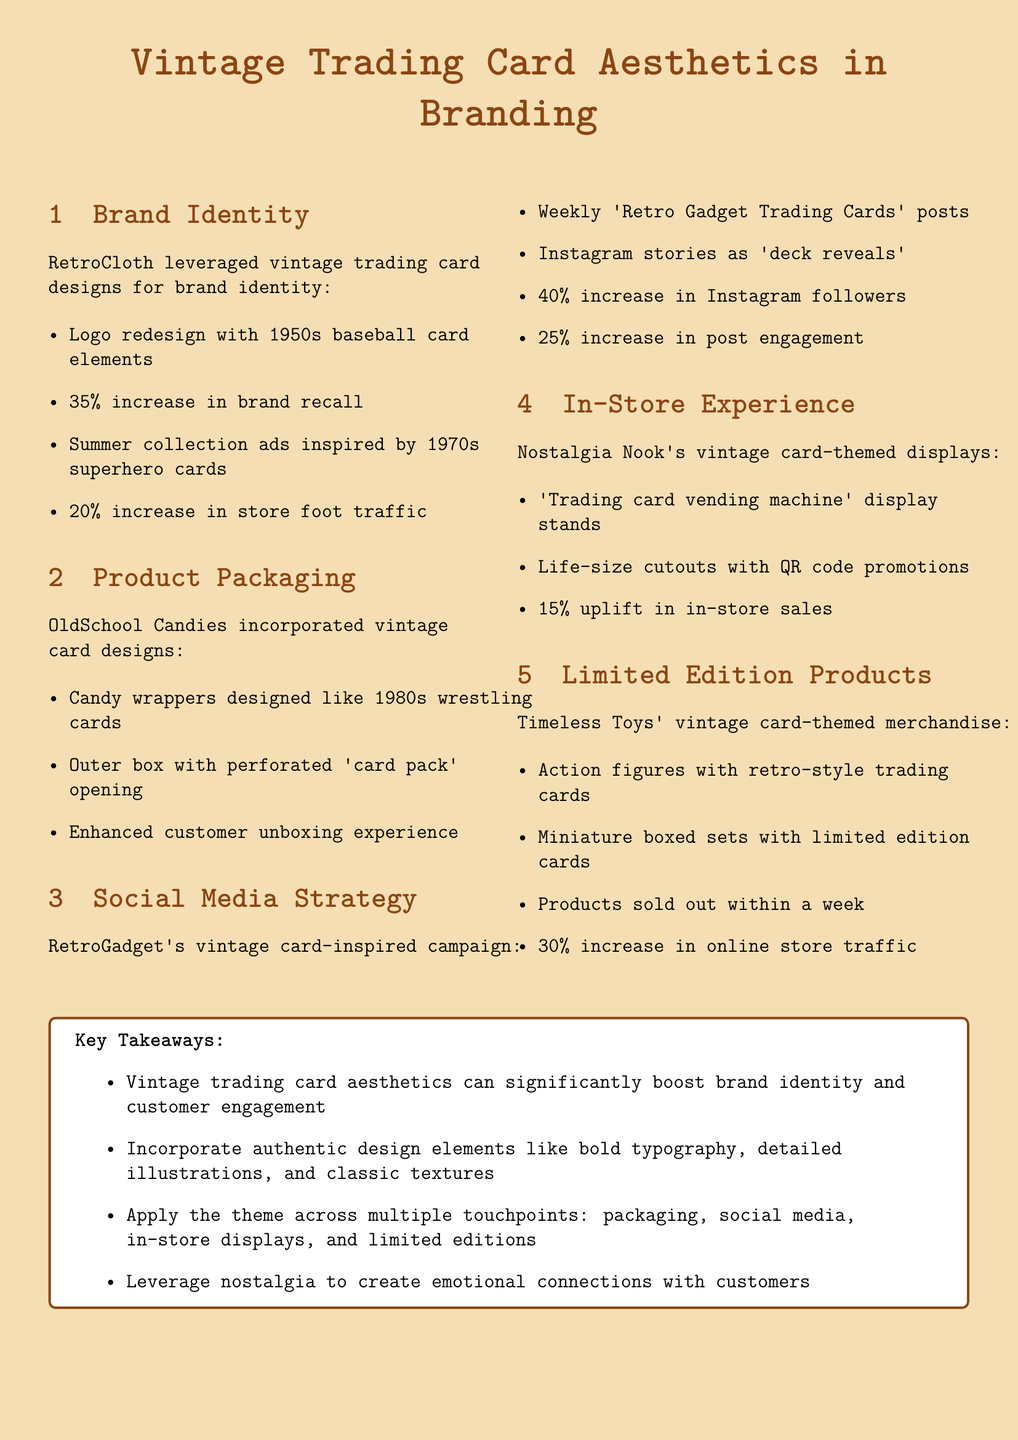What was the increase in brand recall for RetroCloth? The document states that RetroCloth experienced a 35% increase in brand recall through incorporating vintage trading card designs.
Answer: 35% What inspired OldSchool Candies' product packaging? The candy wrappers were designed like 1980s wrestling cards, as mentioned in the product packaging section.
Answer: 1980s wrestling cards What percentage increase in Instagram followers did RetroGadget achieve? RetroGadget's vintage card-inspired campaign led to a 40% increase in Instagram followers.
Answer: 40% What type of display did Nostalgia Nook implement? Nostalgia Nook featured a 'Trading card vending machine' display stand, as highlighted in the in-store experience section.
Answer: Trading card vending machine What was the result of Timeless Toys' vintage card-themed merchandise sales? The document indicates that Timeless Toys' products sold out within a week, showcasing the popularity of their vintage card-themed merchandise.
Answer: Sold out within a week What is a key takeaway regarding vintage trading card aesthetics? One key takeaway from the document is that vintage trading card aesthetics can significantly boost brand identity and customer engagement.
Answer: Boost brand identity and customer engagement What specific design elements should be incorporated according to the key takeaways? The key takeaways suggest incorporating authentic design elements like bold typography, detailed illustrations, and classic textures.
Answer: Bold typography, detailed illustrations, classic textures What percentage uplift in in-store sales did Nostalgia Nook see? The document states that Nostalgia Nook experienced a 15% uplift in in-store sales after implementing vintage card-themed displays.
Answer: 15% What was the increase in online store traffic for Timeless Toys? Timeless Toys achieved a 30% increase in online store traffic as a result of their vintage card-themed merchandise strategy.
Answer: 30% 